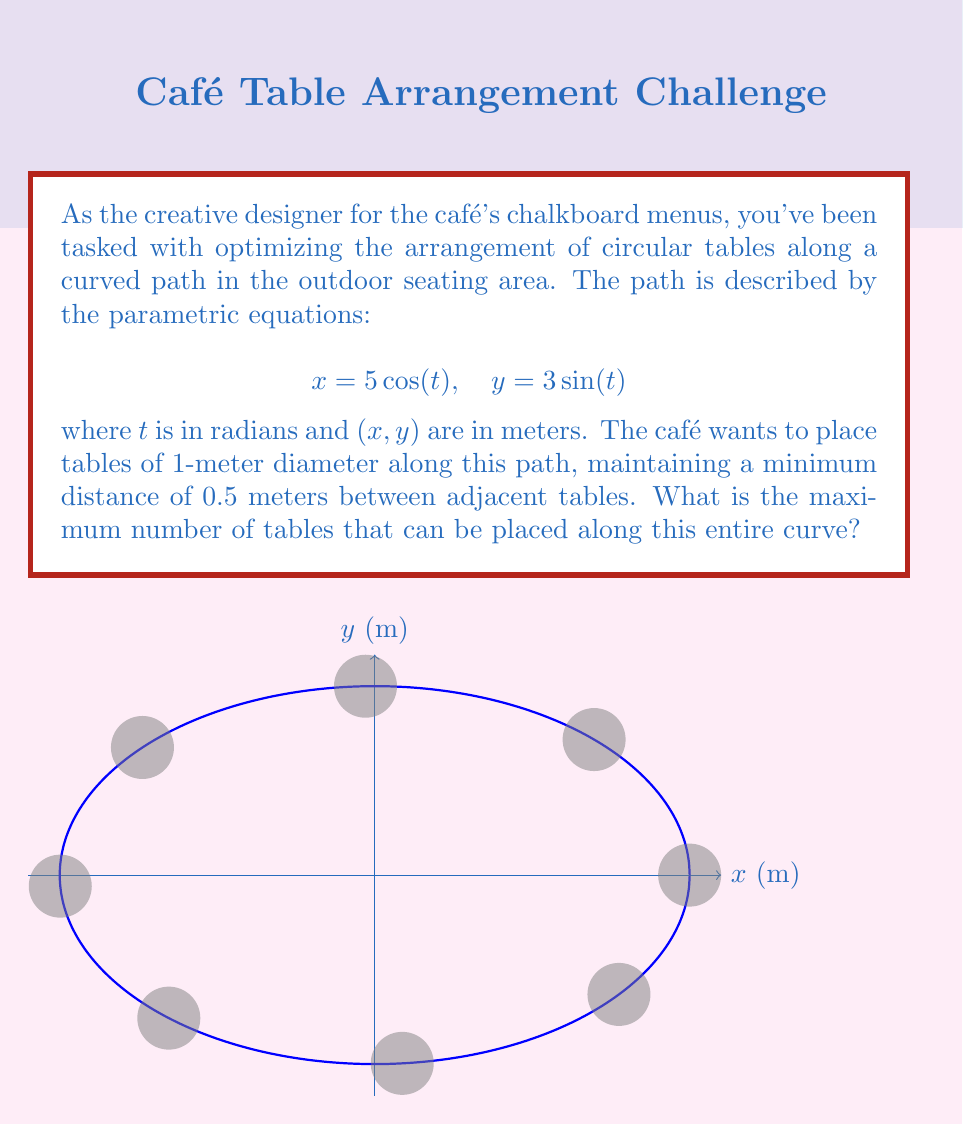Provide a solution to this math problem. Let's approach this step-by-step:

1) First, we need to calculate the total length of the curve. The length of a parametric curve is given by the formula:

   $$L = \int_a^b \sqrt{\left(\frac{dx}{dt}\right)^2 + \left(\frac{dy}{dt}\right)^2} dt$$

2) For our curve:
   $$\frac{dx}{dt} = -5\sin(t), \frac{dy}{dt} = 3\cos(t)$$

3) Substituting into the length formula:
   $$L = \int_0^{2\pi} \sqrt{25\sin^2(t) + 9\cos^2(t)} dt$$

4) This integral doesn't have a simple closed form, but we can evaluate it numerically to get:
   $$L \approx 25.13 \text{ meters}$$

5) Now, we need to consider the space each table occupies. Each table has a diameter of 1 meter, and we need to maintain a 0.5-meter gap between tables. So each table effectively occupies 1.5 meters of the path.

6) The number of tables we can fit is the total length divided by the space each table occupies, rounded down:

   $$\text{Number of tables} = \left\lfloor\frac{25.13}{1.5}\right\rfloor = \left\lfloor16.75\right\rfloor = 16$$

Therefore, the maximum number of tables that can be placed along this curve is 16.
Answer: 16 tables 